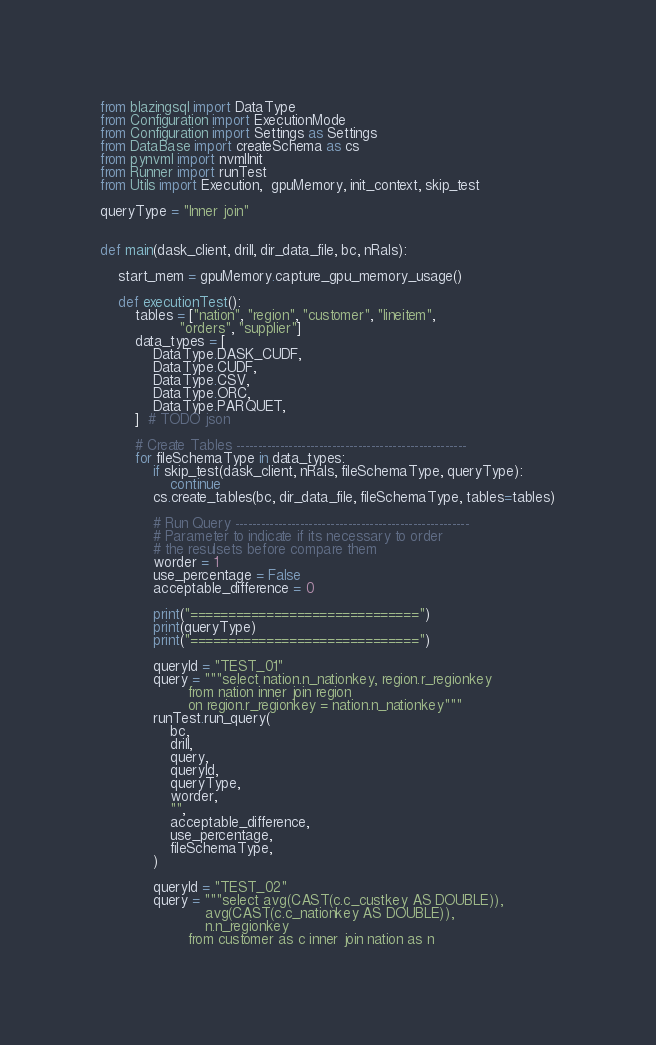Convert code to text. <code><loc_0><loc_0><loc_500><loc_500><_Python_>from blazingsql import DataType
from Configuration import ExecutionMode
from Configuration import Settings as Settings
from DataBase import createSchema as cs
from pynvml import nvmlInit
from Runner import runTest
from Utils import Execution,  gpuMemory, init_context, skip_test

queryType = "Inner join"


def main(dask_client, drill, dir_data_file, bc, nRals):

    start_mem = gpuMemory.capture_gpu_memory_usage()

    def executionTest():
        tables = ["nation", "region", "customer", "lineitem",
                  "orders", "supplier"]
        data_types = [
            DataType.DASK_CUDF,
            DataType.CUDF,
            DataType.CSV,
            DataType.ORC,
            DataType.PARQUET,
        ]  # TODO json

        # Create Tables -----------------------------------------------------
        for fileSchemaType in data_types:
            if skip_test(dask_client, nRals, fileSchemaType, queryType):
                continue
            cs.create_tables(bc, dir_data_file, fileSchemaType, tables=tables)

            # Run Query ------------------------------------------------------
            # Parameter to indicate if its necessary to order
            # the resulsets before compare them
            worder = 1
            use_percentage = False
            acceptable_difference = 0

            print("==============================")
            print(queryType)
            print("==============================")

            queryId = "TEST_01"
            query = """select nation.n_nationkey, region.r_regionkey
                    from nation inner join region
                    on region.r_regionkey = nation.n_nationkey"""
            runTest.run_query(
                bc,
                drill,
                query,
                queryId,
                queryType,
                worder,
                "",
                acceptable_difference,
                use_percentage,
                fileSchemaType,
            )

            queryId = "TEST_02"
            query = """select avg(CAST(c.c_custkey AS DOUBLE)),
                        avg(CAST(c.c_nationkey AS DOUBLE)),
                        n.n_regionkey
                    from customer as c inner join nation as n</code> 